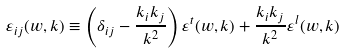Convert formula to latex. <formula><loc_0><loc_0><loc_500><loc_500>\varepsilon _ { i j } ( w , { k } ) \equiv \left ( \delta _ { i j } - \frac { k _ { i } k _ { j } } { k ^ { 2 } } \right ) \varepsilon ^ { t } ( w , { k } ) + \frac { k _ { i } k _ { j } } { k ^ { 2 } } \varepsilon ^ { l } ( w , { k } )</formula> 